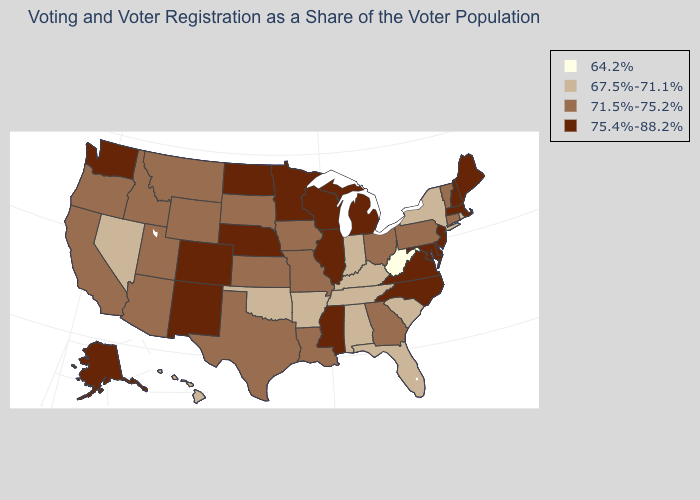Among the states that border Utah , does Nevada have the lowest value?
Be succinct. Yes. Which states have the lowest value in the USA?
Be succinct. West Virginia. What is the value of Nebraska?
Answer briefly. 75.4%-88.2%. Does Illinois have a higher value than Hawaii?
Concise answer only. Yes. Does Mississippi have the lowest value in the USA?
Concise answer only. No. What is the lowest value in the USA?
Keep it brief. 64.2%. Does Alaska have the lowest value in the West?
Keep it brief. No. Name the states that have a value in the range 67.5%-71.1%?
Concise answer only. Alabama, Arkansas, Florida, Hawaii, Indiana, Kentucky, Nevada, New York, Oklahoma, Rhode Island, South Carolina, Tennessee. What is the value of Virginia?
Write a very short answer. 75.4%-88.2%. Among the states that border California , does Nevada have the highest value?
Give a very brief answer. No. How many symbols are there in the legend?
Keep it brief. 4. What is the highest value in states that border North Dakota?
Quick response, please. 75.4%-88.2%. What is the value of Washington?
Short answer required. 75.4%-88.2%. Does Tennessee have the lowest value in the USA?
Answer briefly. No. Name the states that have a value in the range 64.2%?
Answer briefly. West Virginia. 